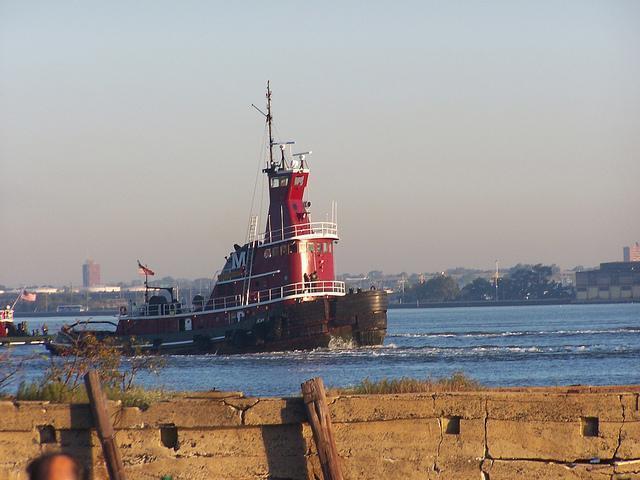The boat here moves under what sort of power?
Indicate the correct response by choosing from the four available options to answer the question.
Options: Solar, engine, wind, tow. Engine. 